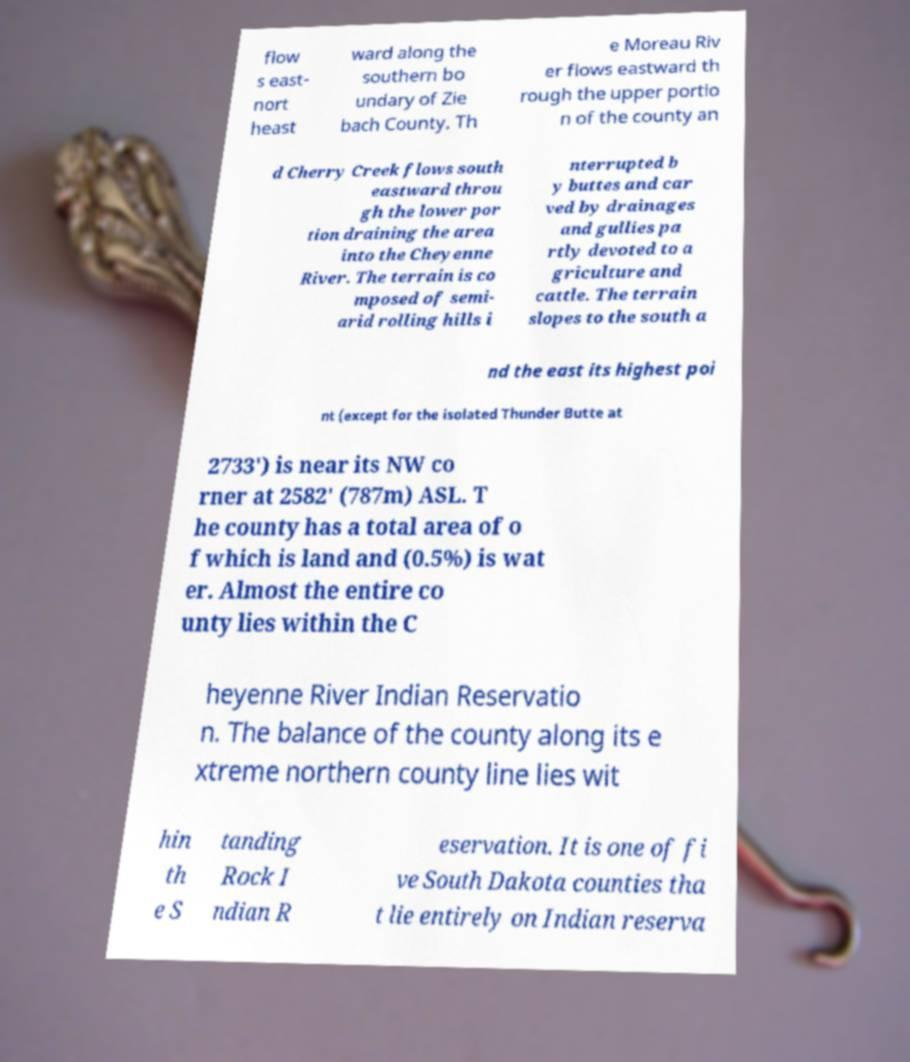Please read and relay the text visible in this image. What does it say? flow s east- nort heast ward along the southern bo undary of Zie bach County. Th e Moreau Riv er flows eastward th rough the upper portio n of the county an d Cherry Creek flows south eastward throu gh the lower por tion draining the area into the Cheyenne River. The terrain is co mposed of semi- arid rolling hills i nterrupted b y buttes and car ved by drainages and gullies pa rtly devoted to a griculture and cattle. The terrain slopes to the south a nd the east its highest poi nt (except for the isolated Thunder Butte at 2733') is near its NW co rner at 2582' (787m) ASL. T he county has a total area of o f which is land and (0.5%) is wat er. Almost the entire co unty lies within the C heyenne River Indian Reservatio n. The balance of the county along its e xtreme northern county line lies wit hin th e S tanding Rock I ndian R eservation. It is one of fi ve South Dakota counties tha t lie entirely on Indian reserva 